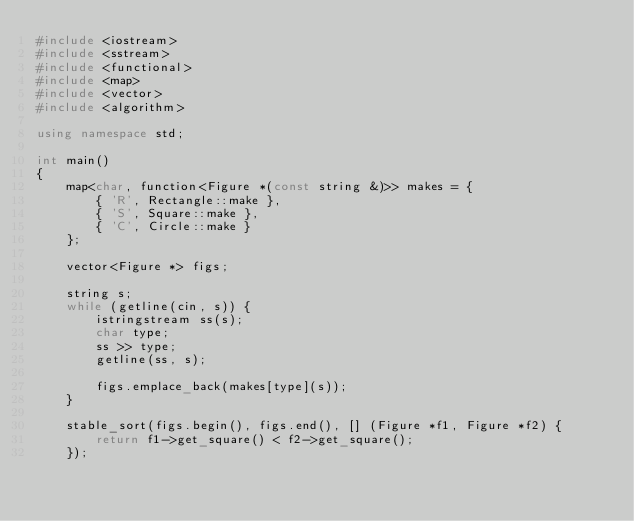<code> <loc_0><loc_0><loc_500><loc_500><_C++_>#include <iostream>
#include <sstream>
#include <functional>
#include <map>
#include <vector>
#include <algorithm>

using namespace std;

int main()
{
    map<char, function<Figure *(const string &)>> makes = {
        { 'R', Rectangle::make },
        { 'S', Square::make },
        { 'C', Circle::make }
    };
    
    vector<Figure *> figs;

    string s;
    while (getline(cin, s)) {
        istringstream ss(s);
        char type;
        ss >> type;
        getline(ss, s);

        figs.emplace_back(makes[type](s));
    }

    stable_sort(figs.begin(), figs.end(), [] (Figure *f1, Figure *f2) {
        return f1->get_square() < f2->get_square();
    });
</code> 